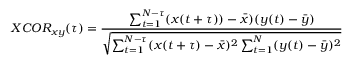<formula> <loc_0><loc_0><loc_500><loc_500>X C O R _ { x y } ( \tau ) = \frac { \sum _ { t = 1 } ^ { N - \tau } ( x ( t + \tau ) ) - \bar { x } ) ( y ( t ) - \bar { y } ) } { \sqrt { \sum _ { t = 1 } ^ { N - \tau } ( x ( t + \tau ) - \bar { x } ) ^ { 2 } \sum _ { t = 1 } ^ { N } ( y ( t ) - \bar { y } ) ^ { 2 } } }</formula> 